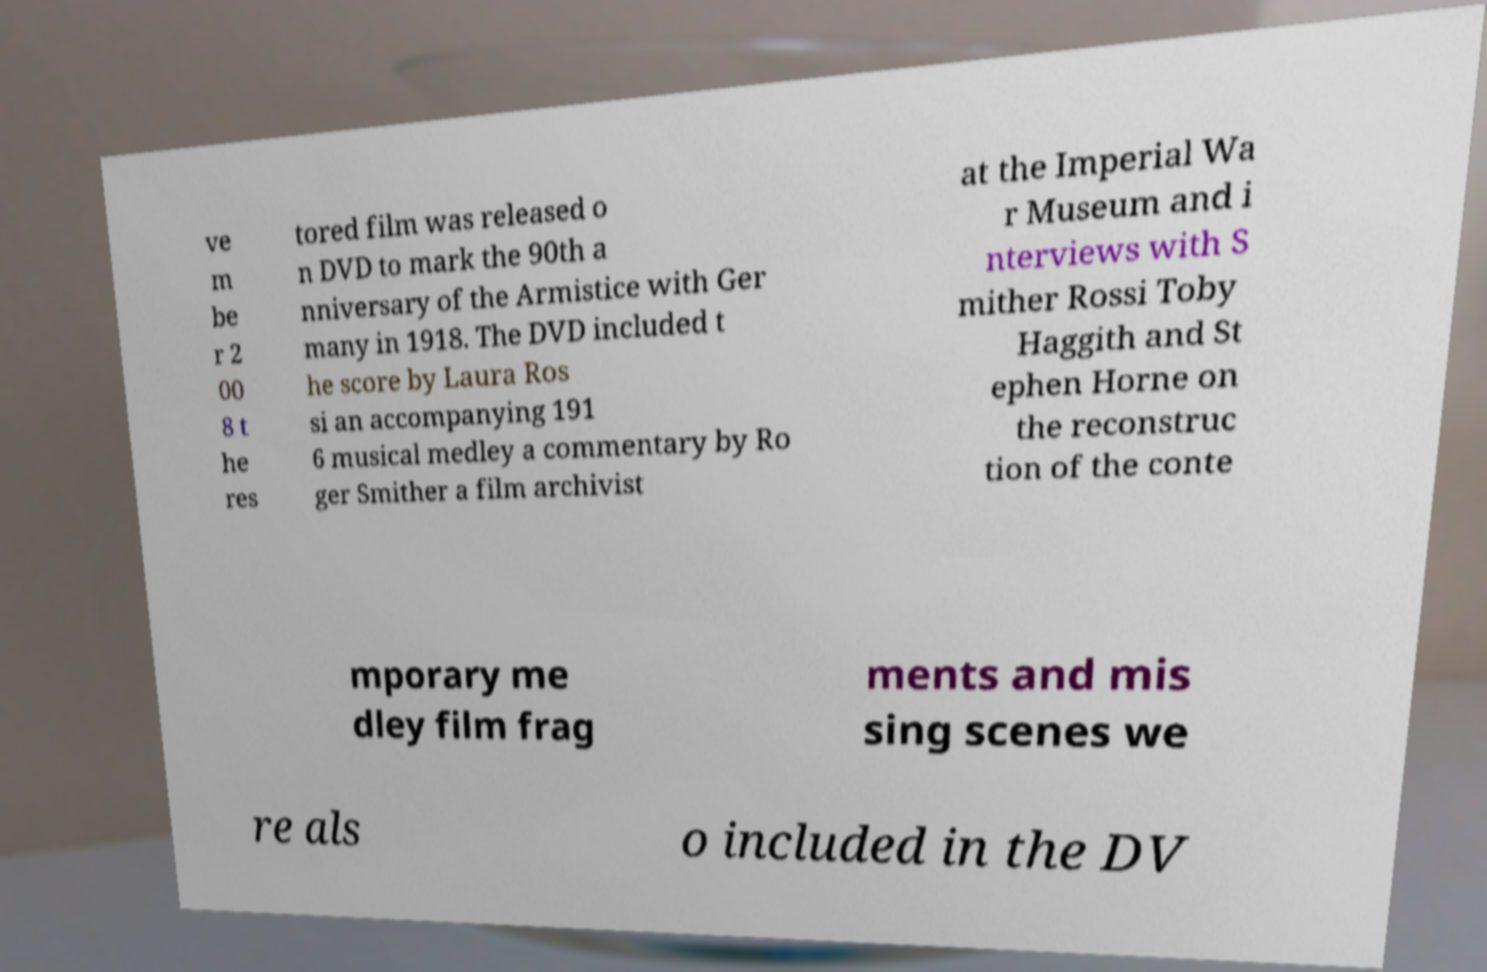Please identify and transcribe the text found in this image. ve m be r 2 00 8 t he res tored film was released o n DVD to mark the 90th a nniversary of the Armistice with Ger many in 1918. The DVD included t he score by Laura Ros si an accompanying 191 6 musical medley a commentary by Ro ger Smither a film archivist at the Imperial Wa r Museum and i nterviews with S mither Rossi Toby Haggith and St ephen Horne on the reconstruc tion of the conte mporary me dley film frag ments and mis sing scenes we re als o included in the DV 